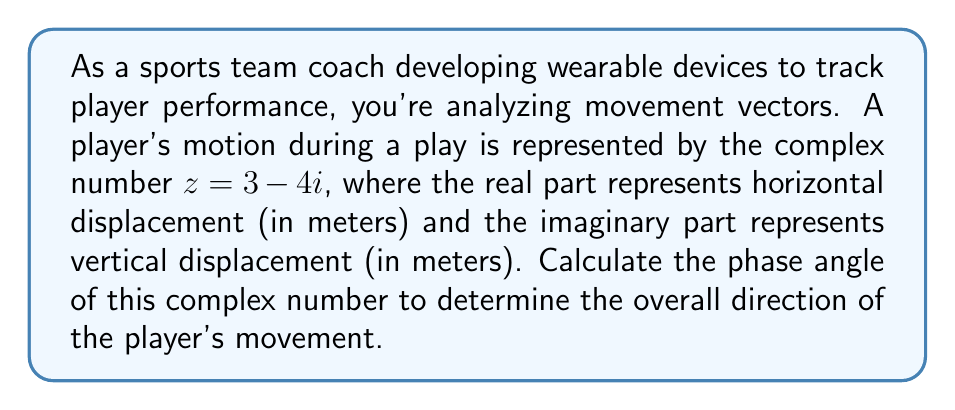Could you help me with this problem? To calculate the phase angle of a complex number $z = a + bi$, we use the arctangent function:

$$\theta = \arctan\left(\frac{b}{a}\right)$$

However, we need to be careful about which quadrant the angle is in. For this, we use the atan2 function, which takes into account the signs of both $a$ and $b$:

$$\theta = \text{atan2}(b, a)$$

For our complex number $z = 3 - 4i$:
$a = 3$ (real part)
$b = -4$ (imaginary part)

Using the atan2 function:

$$\theta = \text{atan2}(-4, 3)$$

This gives us the angle in radians. To convert to degrees, we multiply by $\frac{180}{\pi}$:

$$\theta = \text{atan2}(-4, 3) \cdot \frac{180}{\pi} \approx -53.13010235415598^\circ$$

The negative angle indicates that the movement is in the fourth quadrant of the complex plane, which corresponds to a downward and rightward motion on the field.

[asy]
import geometry;

size(200);
real theta = atan2(-4, 3);
draw((-1,0)--(5,0), arrow=Arrow);
draw((0,-5)--(0,1), arrow=Arrow);
draw((0,0)--(3,-4), arrow=Arrow, red);
label("Re", (5,0), E);
label("Im", (0,1), N);
label("$z = 3-4i$", (3,-4), SE, red);
draw(arc((0,0), 0.8, 0, degrees(theta)), blue);
label("$\theta$", (0.4, -0.2), blue);
[/asy]
Answer: The phase angle of the complex number $z = 3 - 4i$ is approximately $-53.13^\circ$. 